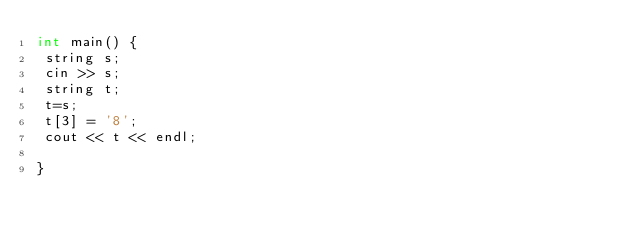<code> <loc_0><loc_0><loc_500><loc_500><_C++_>int main() {
 string s;
 cin >> s;
 string t;
 t=s;
 t[3] = '8';
 cout << t << endl;

}</code> 